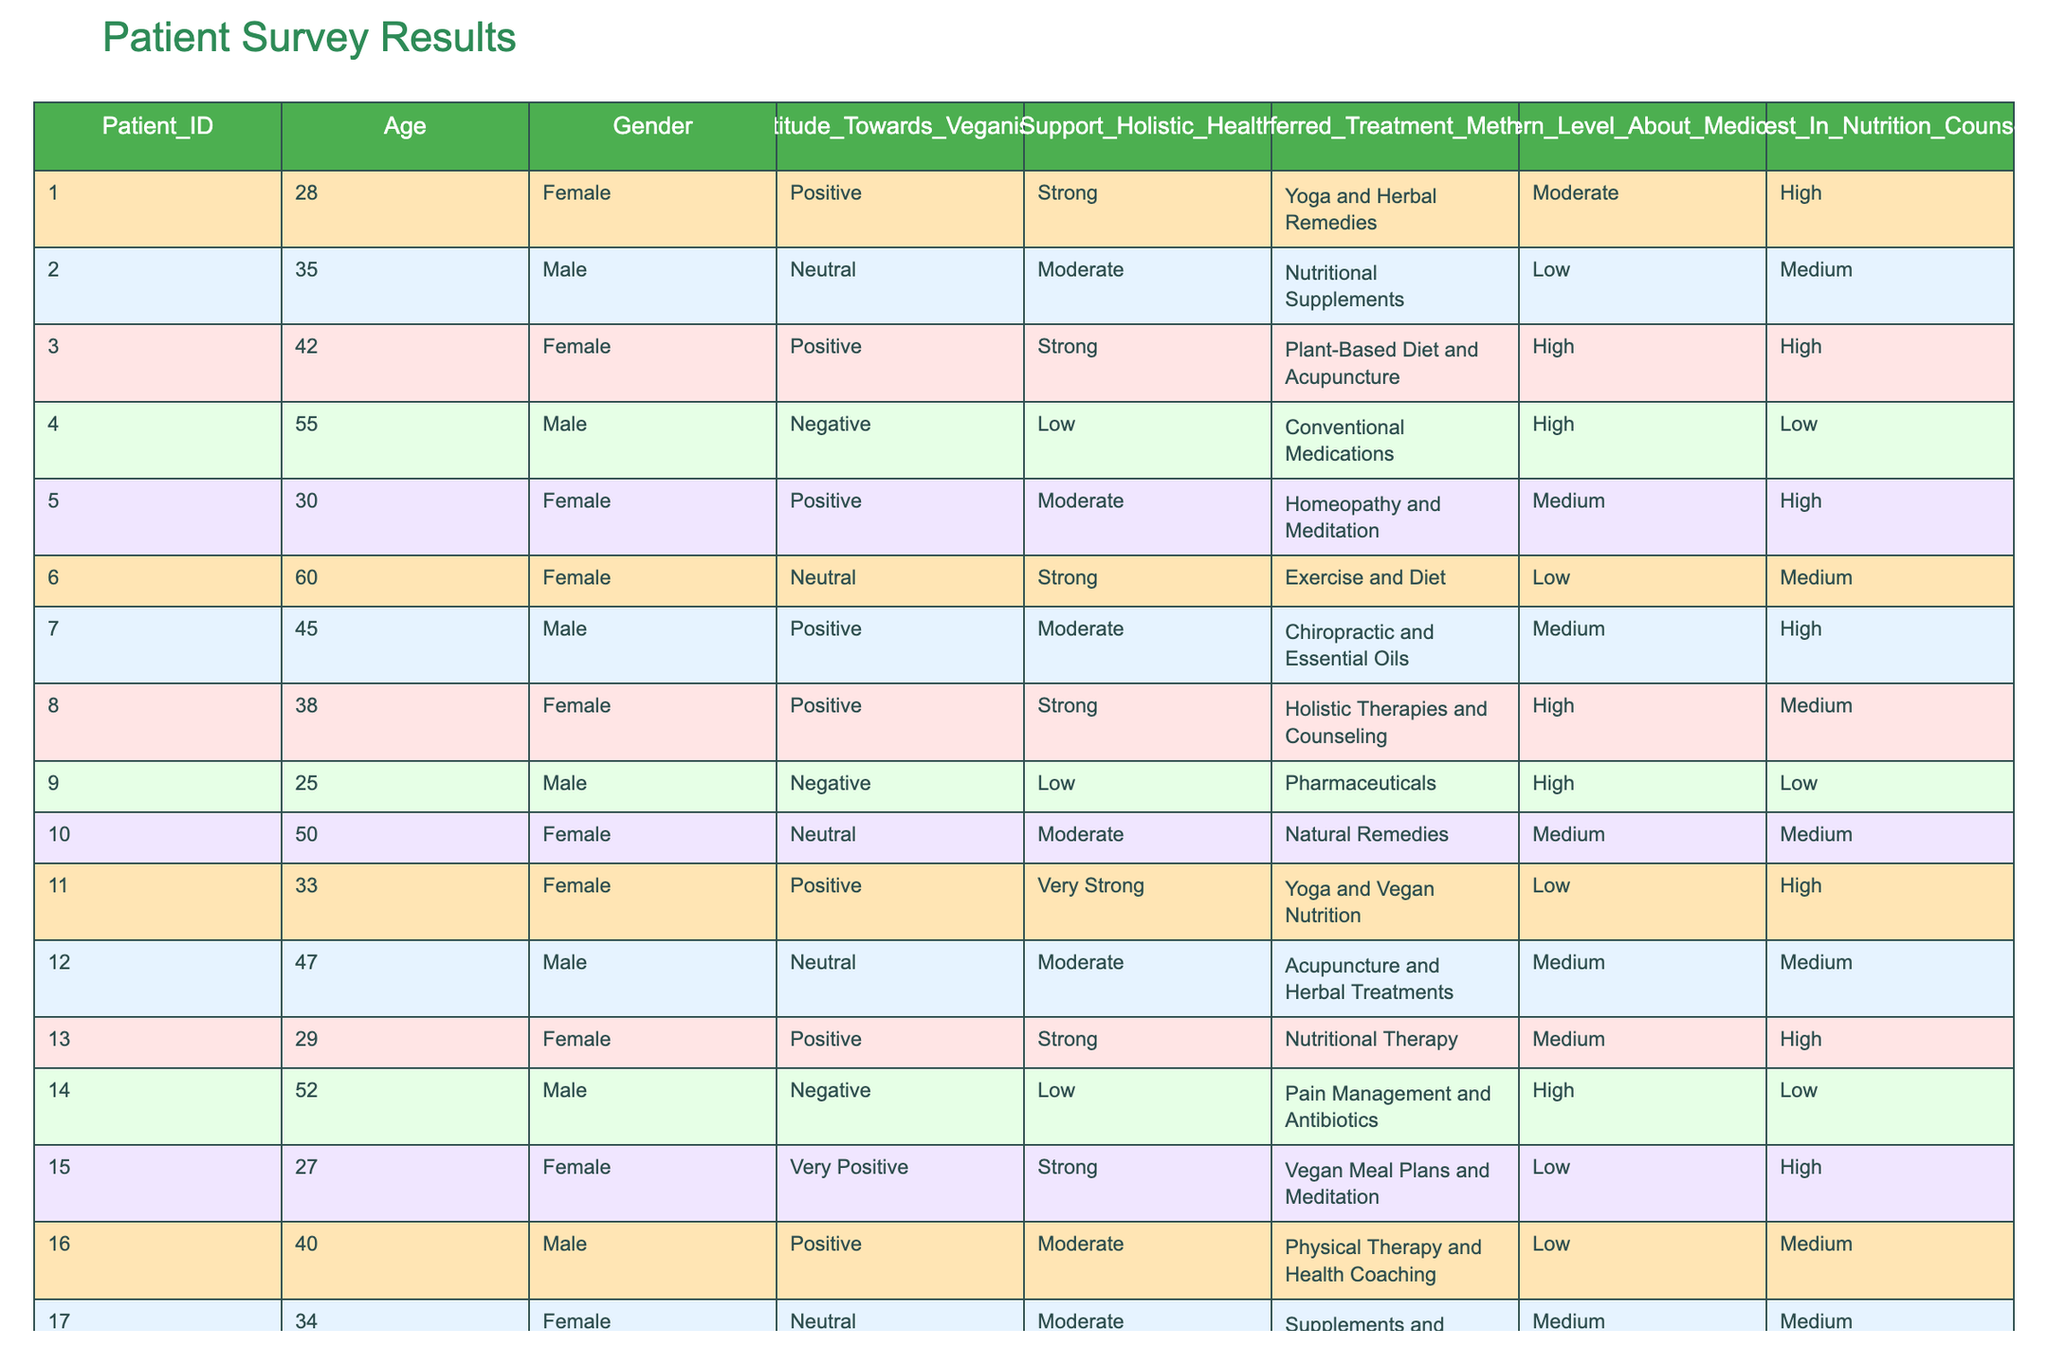What is the most common attitude towards veganism among patients? There are 20 patients surveyed. By reviewing the "Attitude_Towards_Veganism" column, we see that 10 patients have a "Positive" attitude, 6 have a "Neutral" attitude, and 4 have a "Negative" attitude. The "Positive" response is the highest among these three categories.
Answer: Positive How many patients support holistic health practices strongly? In the "Support_Holistic_Health" column, we count the instances of "Strong" and "Very Strong" support. The strong category includes 6 patients and the very strong category includes 2 patients, totaling 8 patients.
Answer: 8 What is the average concern level about medications among patients with a negative attitude towards veganism? First, we identify the patients with a "Negative" attitude (4 patients). Their concern levels are High, High, High, and High. The average is (High + High + High + High) / 4 = High, as all four share the same level of concern.
Answer: High Is there any patient who prefers conventional treatments and has a strong positive attitude towards holistic health? Reviewing the table, we find that the "Negative" attitude is present in patients who also prefer conventional medications, while those with a "Positive" attitude prefer alternative treatments. Therefore, there are no patients in that specific combination.
Answer: No What percentage of female patients are interested in nutrition counseling? In the table, there are 10 female patients in total. The interested females (High and Medium) are 6 out of 10. We calculate the percentage as (6/10) * 100 = 60%.
Answer: 60% 